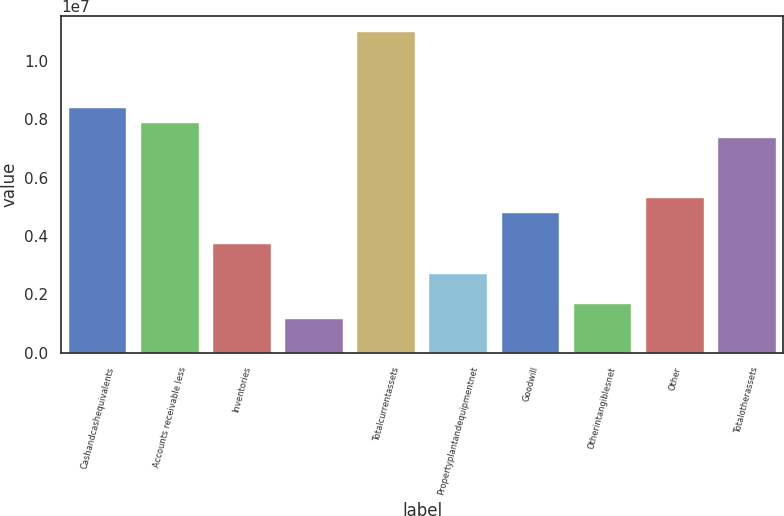Convert chart. <chart><loc_0><loc_0><loc_500><loc_500><bar_chart><fcel>Cashandcashequivalents<fcel>Accounts receivable less<fcel>Inventories<fcel>Unnamed: 3<fcel>Totalcurrentassets<fcel>Propertyplantandequipmentnet<fcel>Goodwill<fcel>Otherintangiblesnet<fcel>Other<fcel>Totalotherassets<nl><fcel>8.40106e+06<fcel>7.88255e+06<fcel>3.73444e+06<fcel>1.14187e+06<fcel>1.09936e+07<fcel>2.69742e+06<fcel>4.77147e+06<fcel>1.66039e+06<fcel>5.28998e+06<fcel>7.36404e+06<nl></chart> 